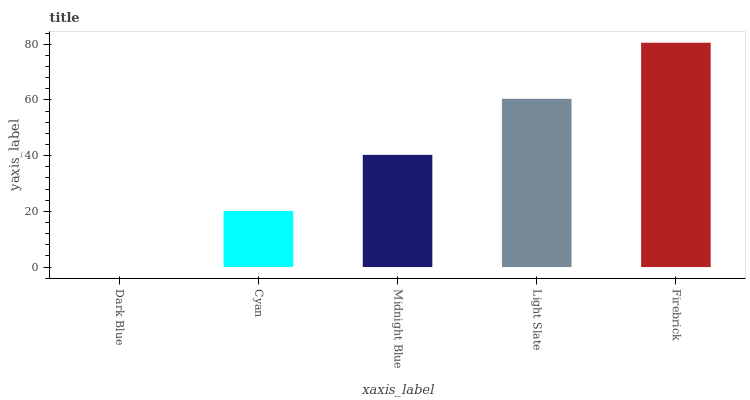Is Cyan the minimum?
Answer yes or no. No. Is Cyan the maximum?
Answer yes or no. No. Is Cyan greater than Dark Blue?
Answer yes or no. Yes. Is Dark Blue less than Cyan?
Answer yes or no. Yes. Is Dark Blue greater than Cyan?
Answer yes or no. No. Is Cyan less than Dark Blue?
Answer yes or no. No. Is Midnight Blue the high median?
Answer yes or no. Yes. Is Midnight Blue the low median?
Answer yes or no. Yes. Is Firebrick the high median?
Answer yes or no. No. Is Light Slate the low median?
Answer yes or no. No. 